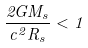<formula> <loc_0><loc_0><loc_500><loc_500>\frac { 2 G M _ { s } } { c ^ { 2 } R _ { s } } < 1</formula> 